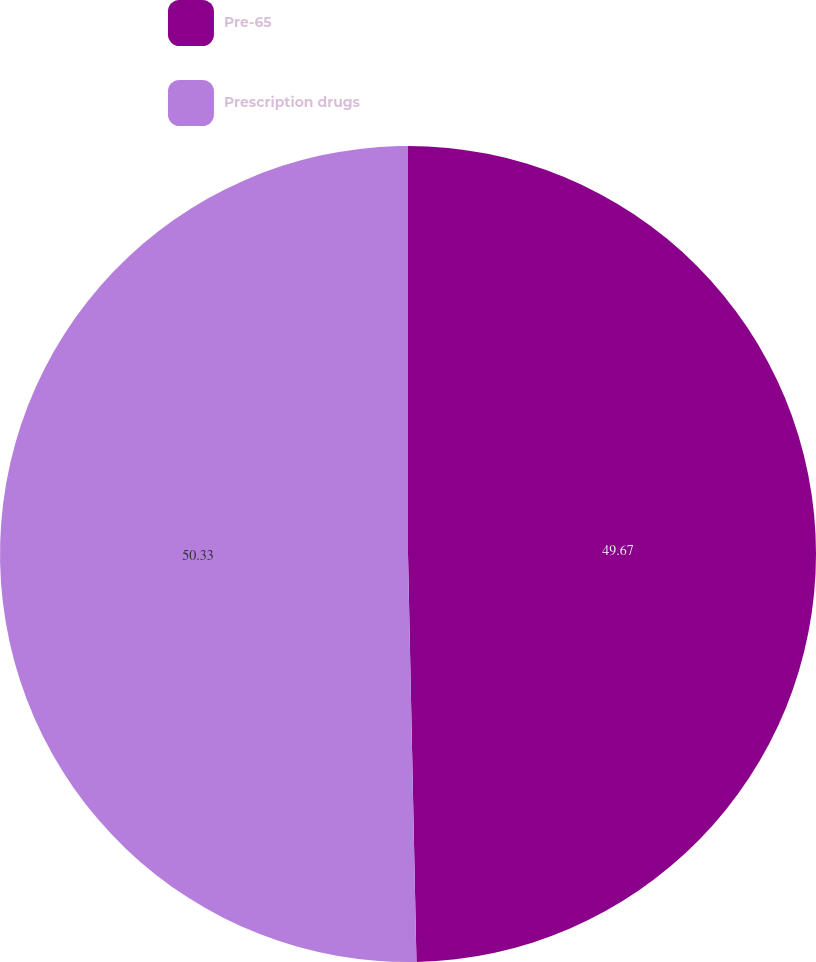<chart> <loc_0><loc_0><loc_500><loc_500><pie_chart><fcel>Pre-65<fcel>Prescription drugs<nl><fcel>49.67%<fcel>50.33%<nl></chart> 